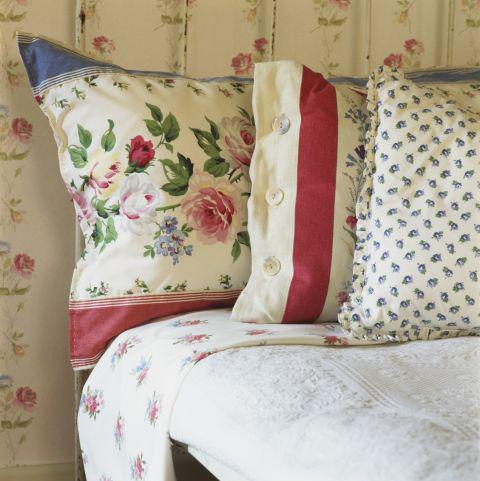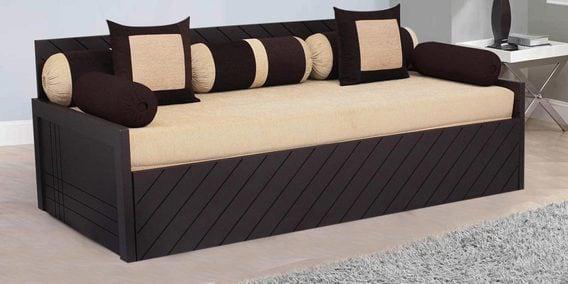The first image is the image on the left, the second image is the image on the right. Considering the images on both sides, is "The left and right image contains the same number of pillow place on the bed." valid? Answer yes or no. No. 